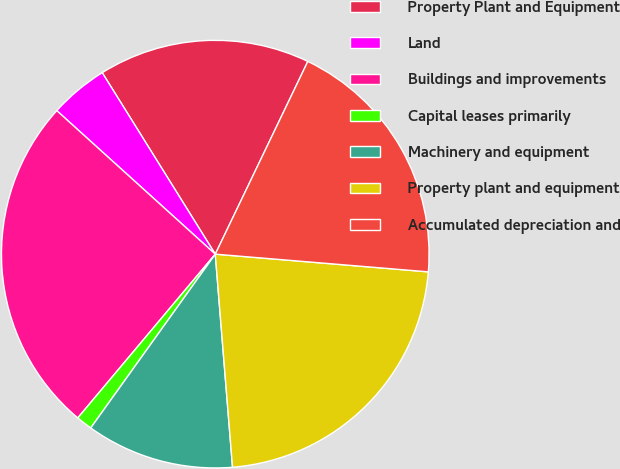<chart> <loc_0><loc_0><loc_500><loc_500><pie_chart><fcel>Property Plant and Equipment<fcel>Land<fcel>Buildings and improvements<fcel>Capital leases primarily<fcel>Machinery and equipment<fcel>Property plant and equipment<fcel>Accumulated depreciation and<nl><fcel>15.99%<fcel>4.42%<fcel>25.59%<fcel>1.22%<fcel>11.18%<fcel>22.39%<fcel>19.19%<nl></chart> 